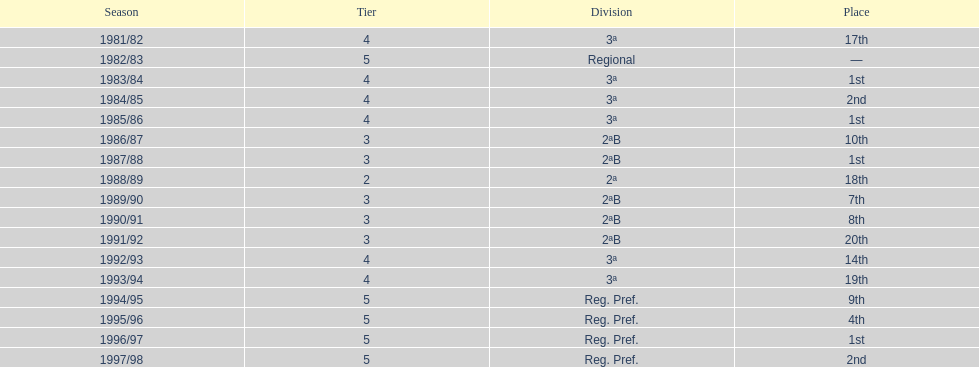During which season(s) did the first place occur? 1983/84, 1985/86, 1987/88, 1996/97. 